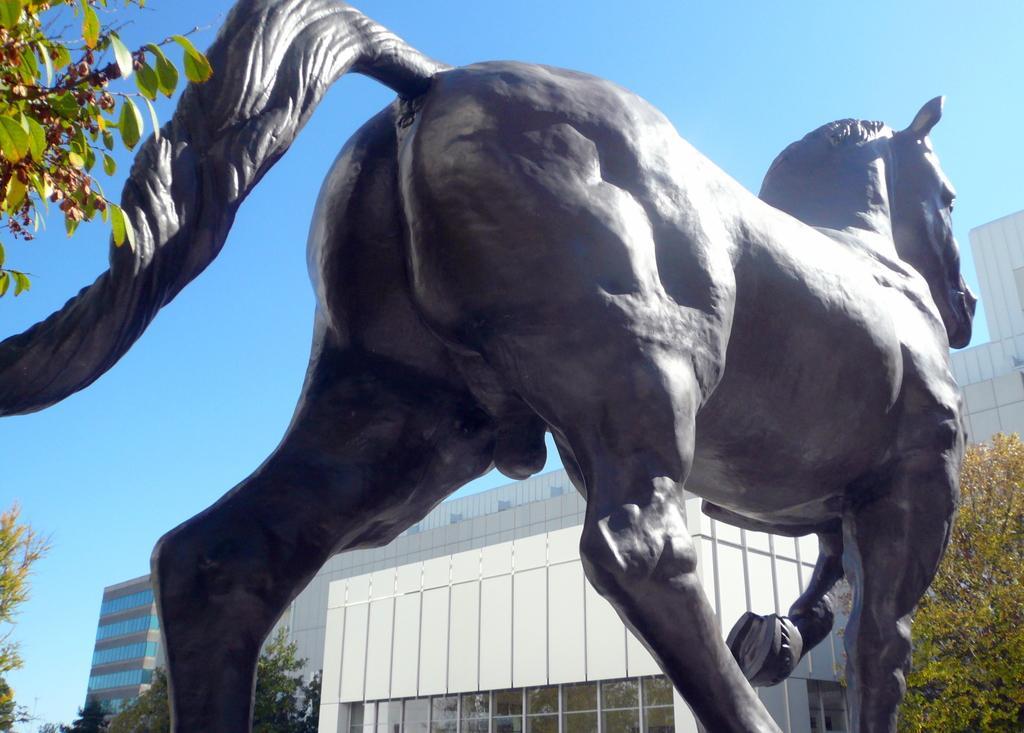How would you summarize this image in a sentence or two? In the picture I can see a statue of the horse and there is a tree in the left corner and there are few buildings and trees in the background. 